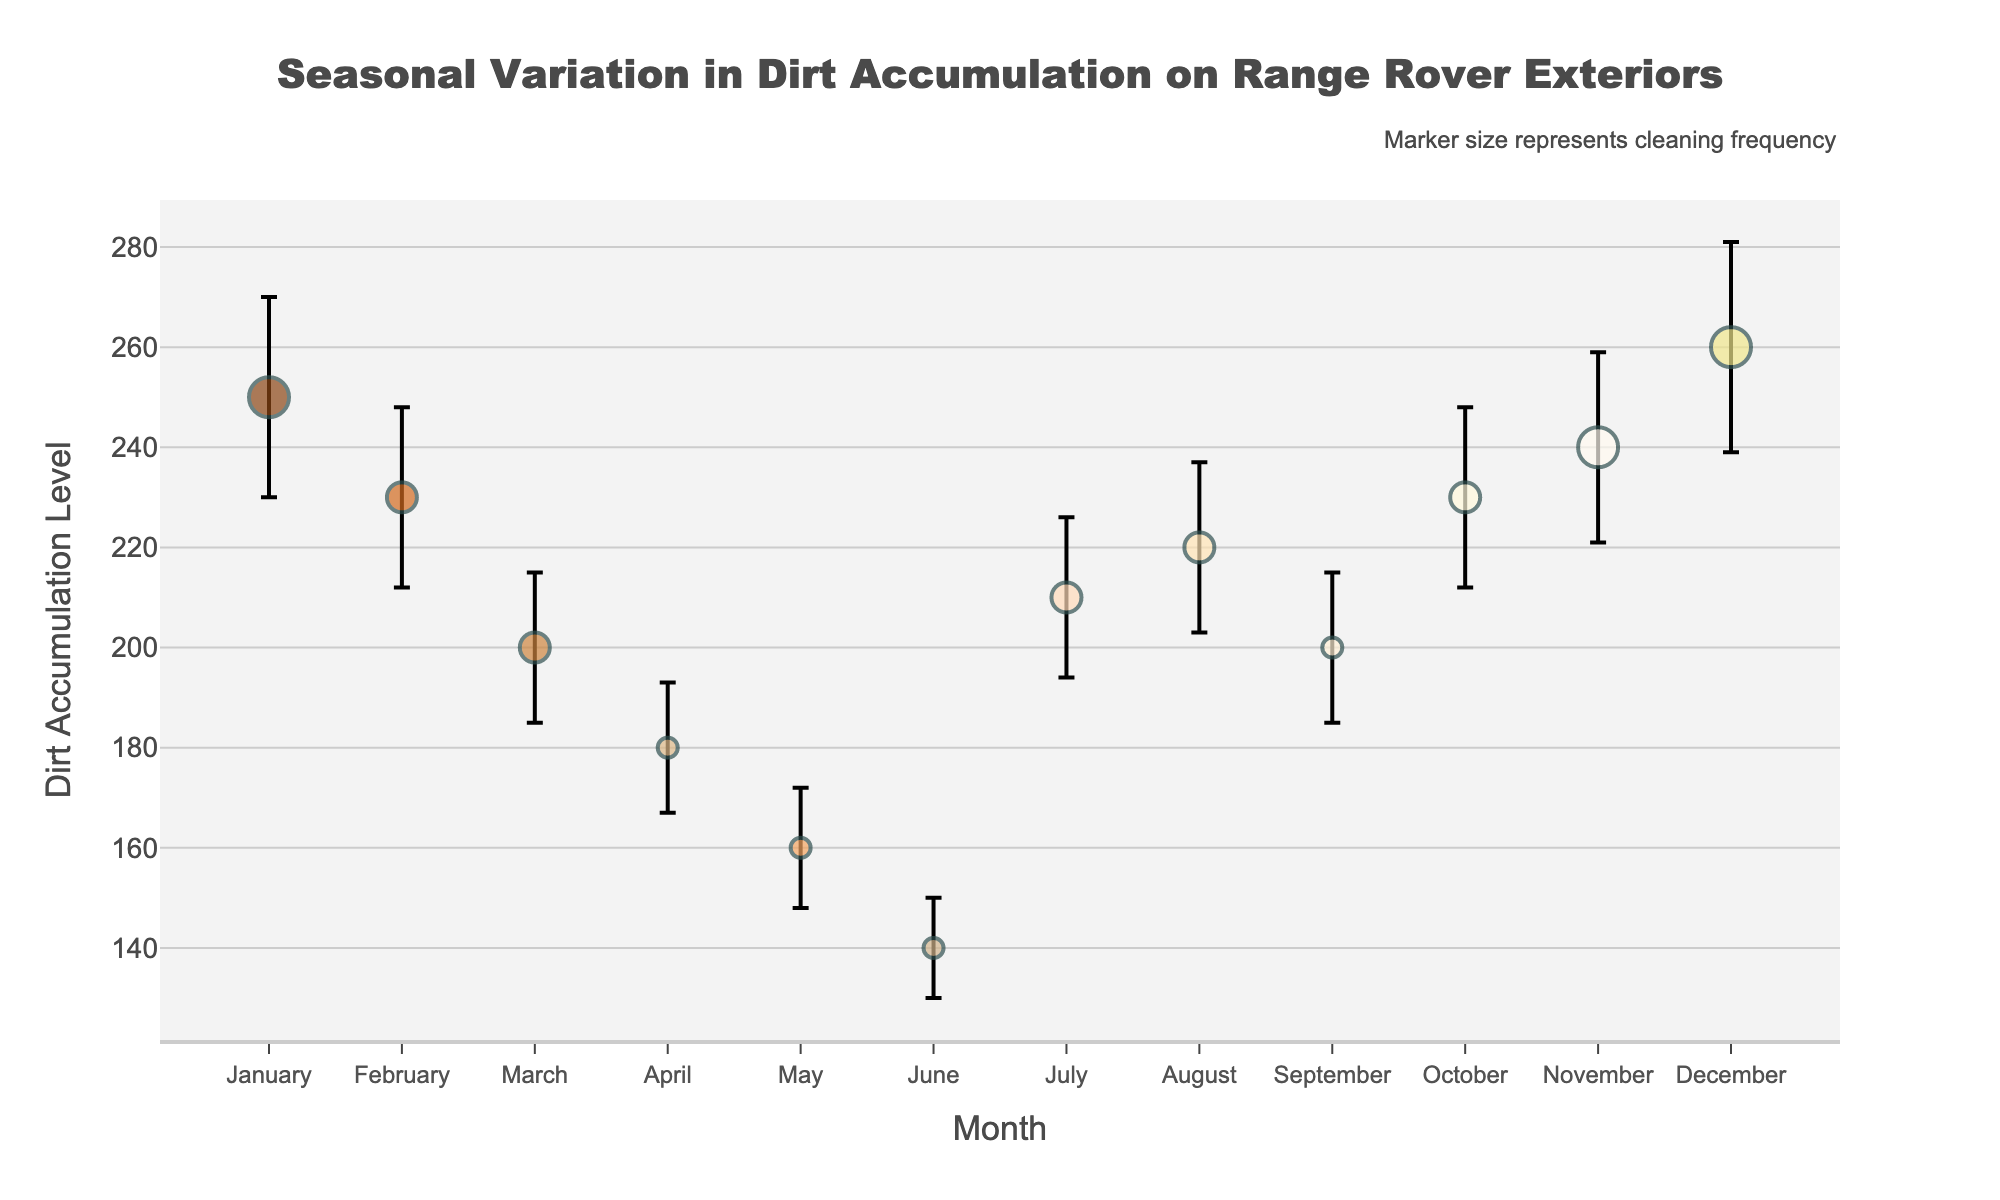What is the title of the plot? The title is displayed prominently at the top of the plot in a large font size. It reads "Seasonal Variation in Dirt Accumulation on Range Rover Exteriors."
Answer: Seasonal Variation in Dirt Accumulation on Range Rover Exteriors Which month shows the highest level of dirt accumulation? By examining the y-values on the plot, December has the highest dirt accumulation level at approximately 260.
Answer: December What is the cleaning frequency in June? The size of the markers represents the cleaning frequency. In June, the marker size corresponds to a cleaning frequency of 2.
Answer: 2 In which month do we see the lowest dirt accumulation level, and what is the value? From the plot, the lowest dirt accumulation level can be seen in June, with a value of around 140.
Answer: June, 140 Compare the dirt accumulation levels between July and February. Which month accumulates more dirt and by how much? Dirt accumulation levels can be compared by referencing the y-axis. July has about 210 while February has about 230. Therefore, February accumulates 20 more dirt units than July.
Answer: February by 20 Which months have a cleaning frequency of 4? There are distinct markers indicating a frequency of 4 in January, November, and December.
Answer: January, November, December What is the dirt accumulation level in November and the mean error associated with it? The dirt accumulation level in November is about 240, and the associated mean error is indicated as 19.
Answer: 240, 19 What pattern do you observe in the dirt accumulation levels between March and June, and how does this correlate with cleaning frequency? From March to June, dirt levels steadily decrease from 200 to 140. Cleaning frequency remains constant at 2 during this period, suggesting less frequent cleaning as the dirt decreases.
Answer: Dirt decreases, cleaning frequency constant Does any month with 3 cleaning frequencies show a dirt accumulation level of 200 or above? For months with a cleaning frequency of 3, we see that February, July, August, and October have dirt accumulation levels of 200 or higher.
Answer: February, July, August, October Calculate the average dirt accumulation level for the months of January, February, and December. Sum the dirt accumulation levels for January (250), February (230), and December (260). The total is 740. Divide by 3 to get the average: 740/3 ≈ 246.67.
Answer: 246.67 